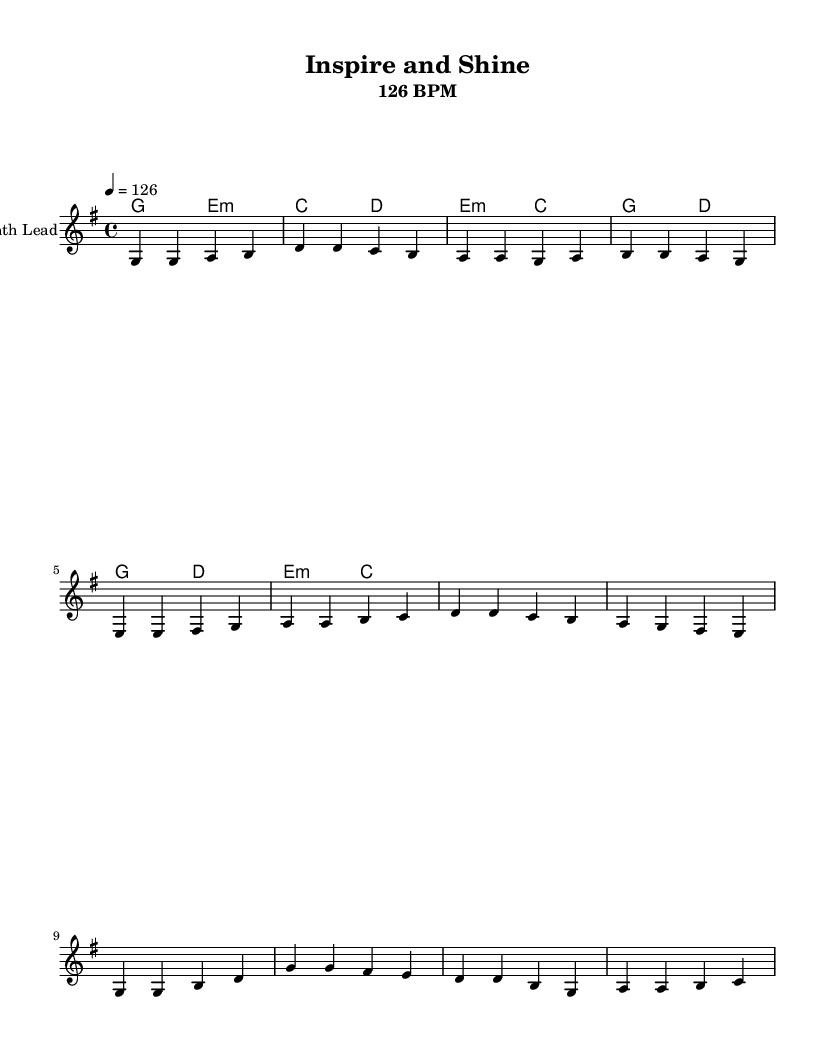What is the key signature of this music? The key signature used here is G major, which contains one sharp (F#). This can be identified by looking at the key signature at the beginning of the score.
Answer: G major What is the time signature of this piece? The time signature is found at the start of the score, and it shows 4/4, which means there are 4 beats in each measure, and the quarter note gets one beat.
Answer: 4/4 What is the tempo of the song? The tempo indication at the top of the score states 126 BPM, which means the piece is meant to be played at 126 beats per minute.
Answer: 126 BPM How many measures are there in the verse? By counting the measures in the verse section provided in the score, there are four complete measures indicated before moving to the pre-chorus.
Answer: 4 What is the last note of the chorus section? The last note of the chorus is observed at the end of the melody section for the chorus. The last note shown is C.
Answer: C Which chord is played at the beginning of the pre-chorus? The chord played at the beginning of the pre-chorus is indicated right before the first note of that section. It is an E minor chord.
Answer: E minor What phrase describes the theme of this song? The lyrics of the song, specifically in the chorus, highlight the themes of inspiration and growth, emphasizing the joy of teaching and learning together.
Answer: Inspire and shine 